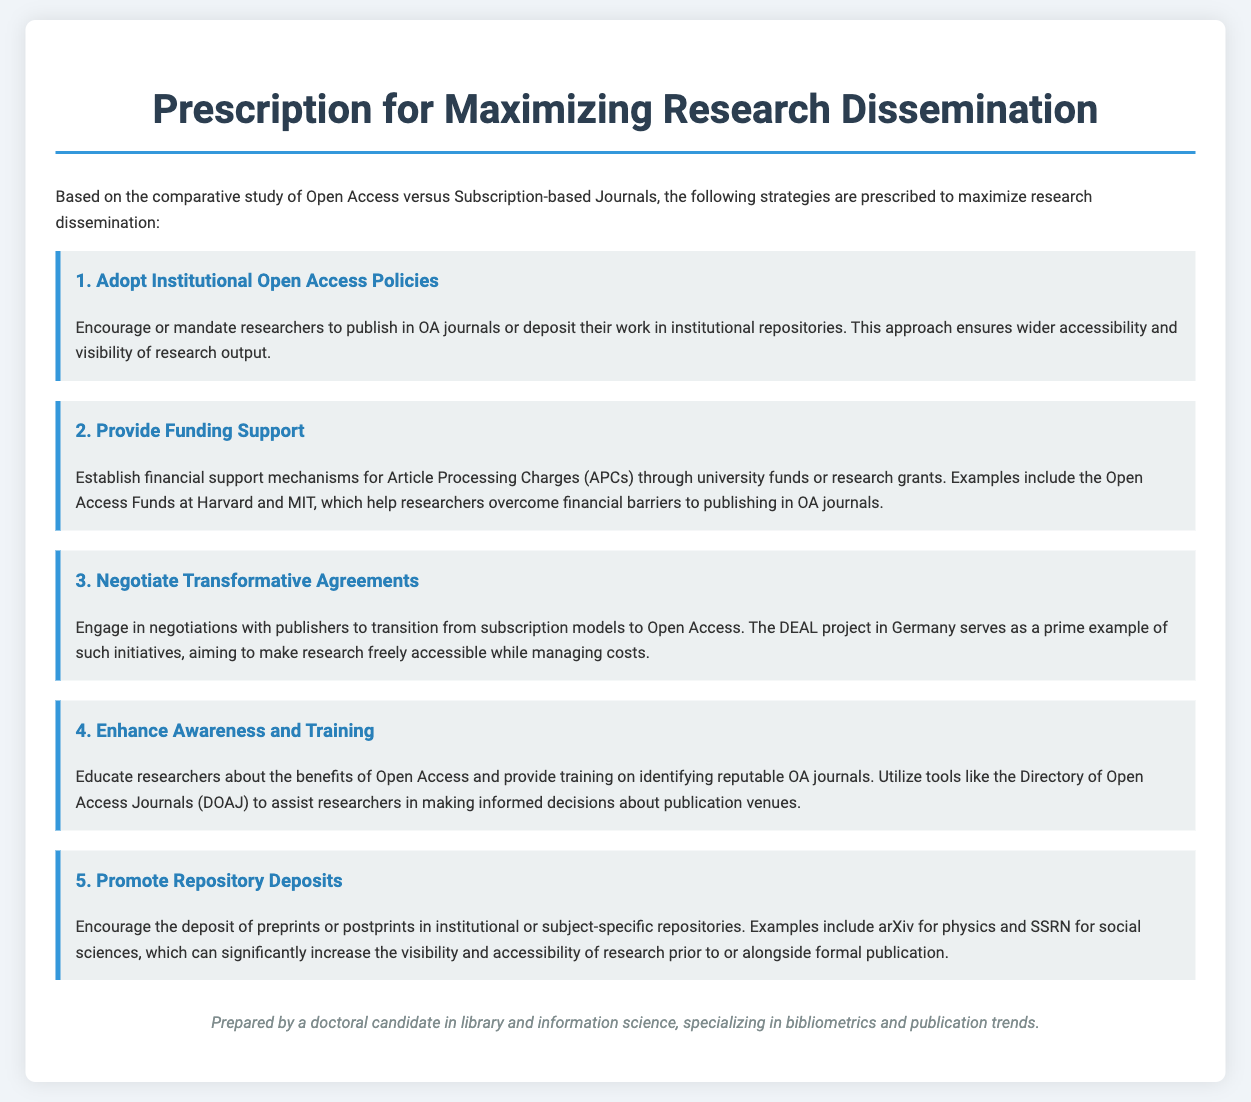what is the title of the document? The title is presented at the top of the document, indicating the main focus of the content.
Answer: Prescription for Maximizing Research Dissemination how many strategies are prescribed to maximize research dissemination? The document lists a total of five distinct strategies for maximizing research dissemination.
Answer: 5 what is the first strategy proposed? The first strategy is highlighted in the document and focuses on institutional policies related to Open Access.
Answer: Adopt Institutional Open Access Policies which funding support example is mentioned in the document? This document provides a specific instance of funding support mechanisms related to Article Processing Charges through notable universities.
Answer: Open Access Funds at Harvard and MIT what is the main purpose of negotiating transformative agreements? The document discusses the goal of this strategy in the context of transitioning journal accessibility models.
Answer: To transition from subscription models to Open Access what tool is suggested for researchers to identify reputable OA journals? The document names a specific resource that can assist researchers in finding suitable Open Access journals.
Answer: Directory of Open Access Journals (DOAJ) which type of repositories are encouraged for deposit of research outputs? The document specifies the types of repositories that researchers should utilize for their work, improving its visibility.
Answer: Institutional or subject-specific repositories what is the focus of training provided to researchers? The training is intended to enhance understanding of Open Access benefits and help identify appropriate publication venues.
Answer: Benefits of Open Access 